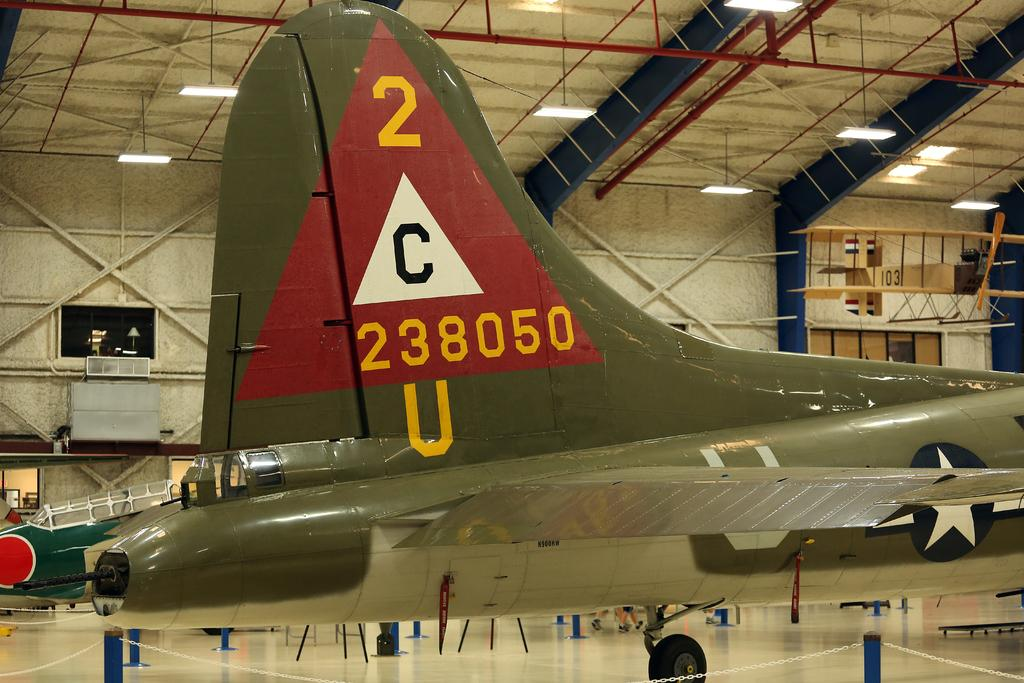Provide a one-sentence caption for the provided image. Come see the 2C238050U plane that it on display now. 